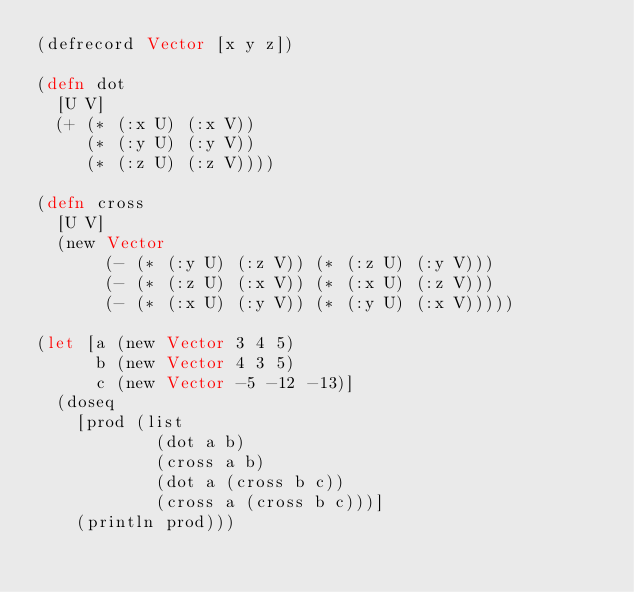Convert code to text. <code><loc_0><loc_0><loc_500><loc_500><_Clojure_>(defrecord Vector [x y z])

(defn dot
  [U V]
  (+ (* (:x U) (:x V))
     (* (:y U) (:y V))
     (* (:z U) (:z V))))

(defn cross
  [U V]
  (new Vector
       (- (* (:y U) (:z V)) (* (:z U) (:y V)))
       (- (* (:z U) (:x V)) (* (:x U) (:z V)))
       (- (* (:x U) (:y V)) (* (:y U) (:x V)))))

(let [a (new Vector 3 4 5)
      b (new Vector 4 3 5)
      c (new Vector -5 -12 -13)]
  (doseq
    [prod (list
            (dot a b)
            (cross a b)
            (dot a (cross b c))
            (cross a (cross b c)))]
    (println prod)))
</code> 